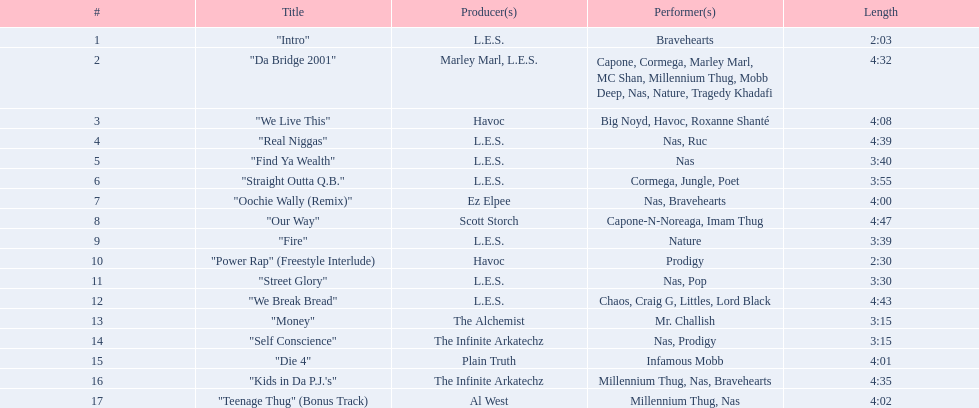What are the entire titles of the songs? "Intro", "Da Bridge 2001", "We Live This", "Real Niggas", "Find Ya Wealth", "Straight Outta Q.B.", "Oochie Wally (Remix)", "Our Way", "Fire", "Power Rap" (Freestyle Interlude), "Street Glory", "We Break Bread", "Money", "Self Conscience", "Die 4", "Kids in Da P.J.'s", "Teenage Thug" (Bonus Track). Who was responsible for producing these tracks? L.E.S., Marley Marl, L.E.S., Ez Elpee, Scott Storch, Havoc, The Alchemist, The Infinite Arkatechz, Plain Truth, Al West. Out of the producers, who crafted the most concise song? L.E.S. How brief was this particular producer's track? 2:03. 